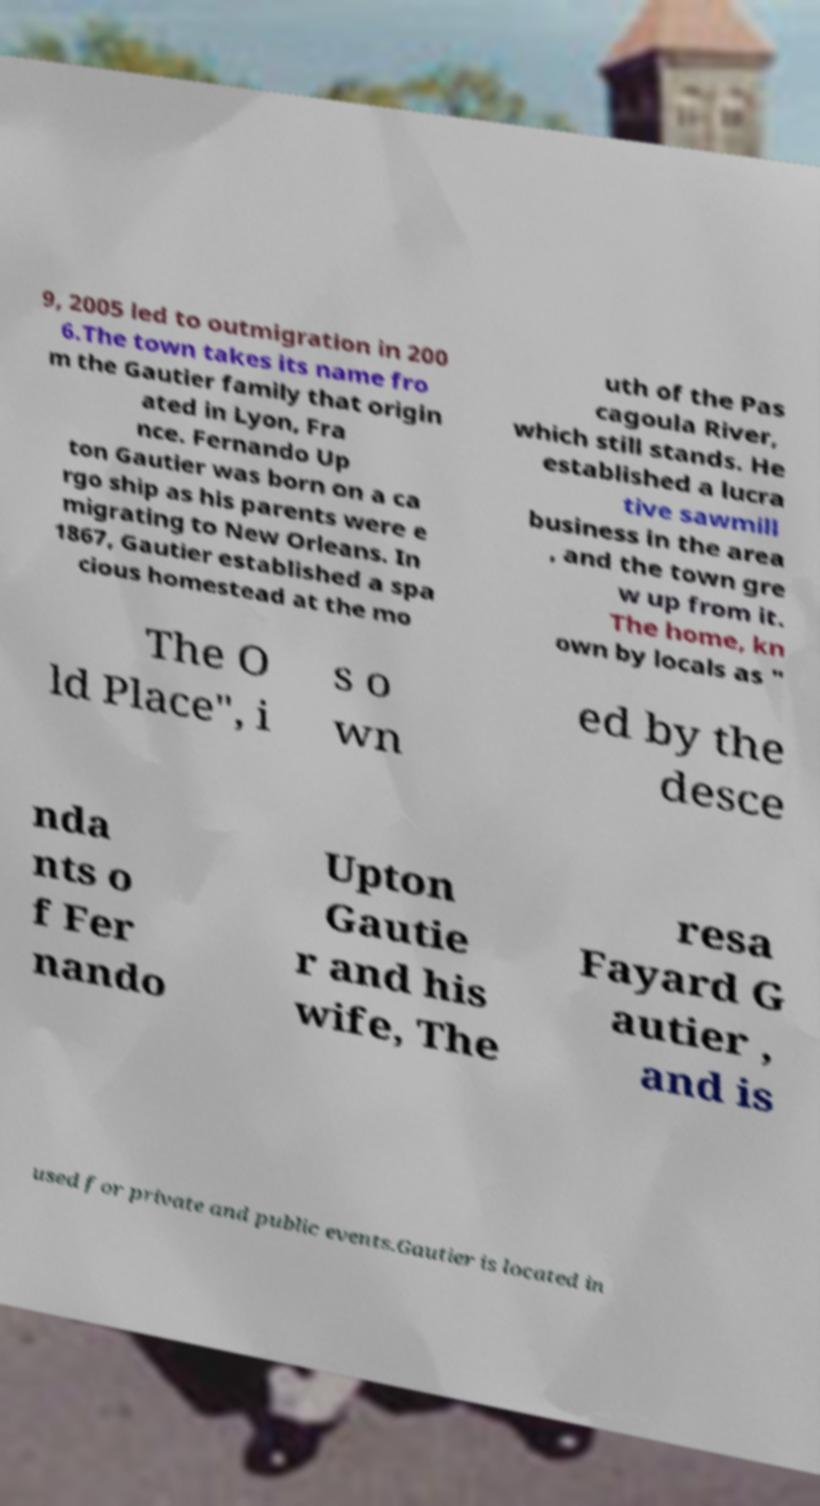Please identify and transcribe the text found in this image. 9, 2005 led to outmigration in 200 6.The town takes its name fro m the Gautier family that origin ated in Lyon, Fra nce. Fernando Up ton Gautier was born on a ca rgo ship as his parents were e migrating to New Orleans. In 1867, Gautier established a spa cious homestead at the mo uth of the Pas cagoula River, which still stands. He established a lucra tive sawmill business in the area , and the town gre w up from it. The home, kn own by locals as " The O ld Place", i s o wn ed by the desce nda nts o f Fer nando Upton Gautie r and his wife, The resa Fayard G autier , and is used for private and public events.Gautier is located in 